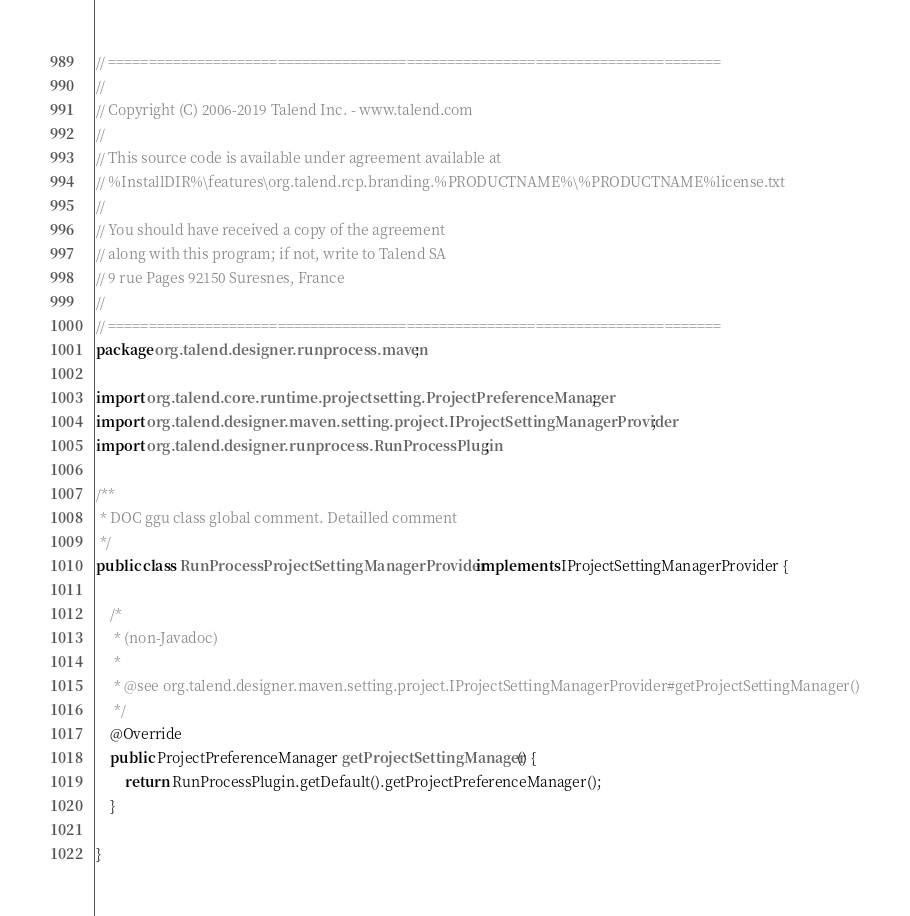Convert code to text. <code><loc_0><loc_0><loc_500><loc_500><_Java_>// ============================================================================
//
// Copyright (C) 2006-2019 Talend Inc. - www.talend.com
//
// This source code is available under agreement available at
// %InstallDIR%\features\org.talend.rcp.branding.%PRODUCTNAME%\%PRODUCTNAME%license.txt
//
// You should have received a copy of the agreement
// along with this program; if not, write to Talend SA
// 9 rue Pages 92150 Suresnes, France
//
// ============================================================================
package org.talend.designer.runprocess.maven;

import org.talend.core.runtime.projectsetting.ProjectPreferenceManager;
import org.talend.designer.maven.setting.project.IProjectSettingManagerProvider;
import org.talend.designer.runprocess.RunProcessPlugin;

/**
 * DOC ggu class global comment. Detailled comment
 */
public class RunProcessProjectSettingManagerProvider implements IProjectSettingManagerProvider {

    /*
     * (non-Javadoc)
     *
     * @see org.talend.designer.maven.setting.project.IProjectSettingManagerProvider#getProjectSettingManager()
     */
    @Override
    public ProjectPreferenceManager getProjectSettingManager() {
        return RunProcessPlugin.getDefault().getProjectPreferenceManager();
    }

}
</code> 